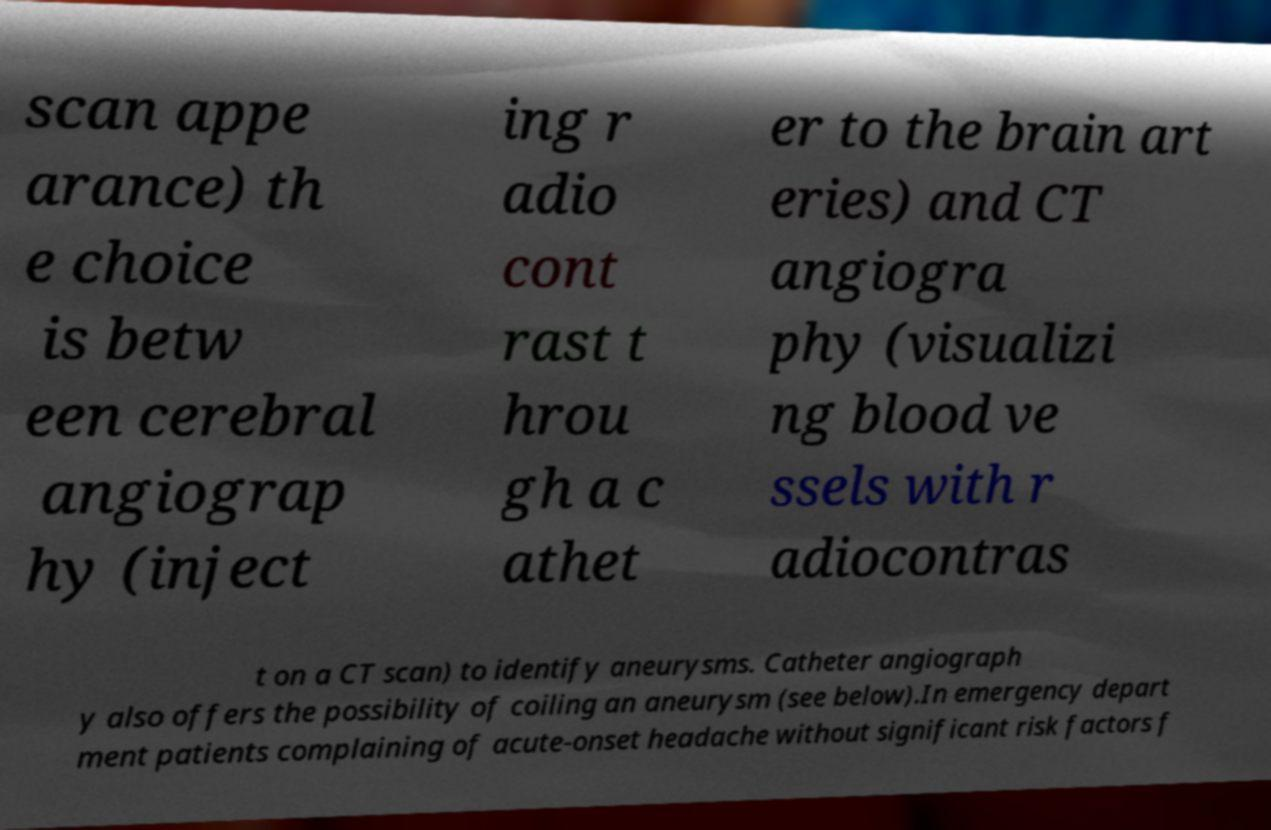Can you accurately transcribe the text from the provided image for me? scan appe arance) th e choice is betw een cerebral angiograp hy (inject ing r adio cont rast t hrou gh a c athet er to the brain art eries) and CT angiogra phy (visualizi ng blood ve ssels with r adiocontras t on a CT scan) to identify aneurysms. Catheter angiograph y also offers the possibility of coiling an aneurysm (see below).In emergency depart ment patients complaining of acute-onset headache without significant risk factors f 